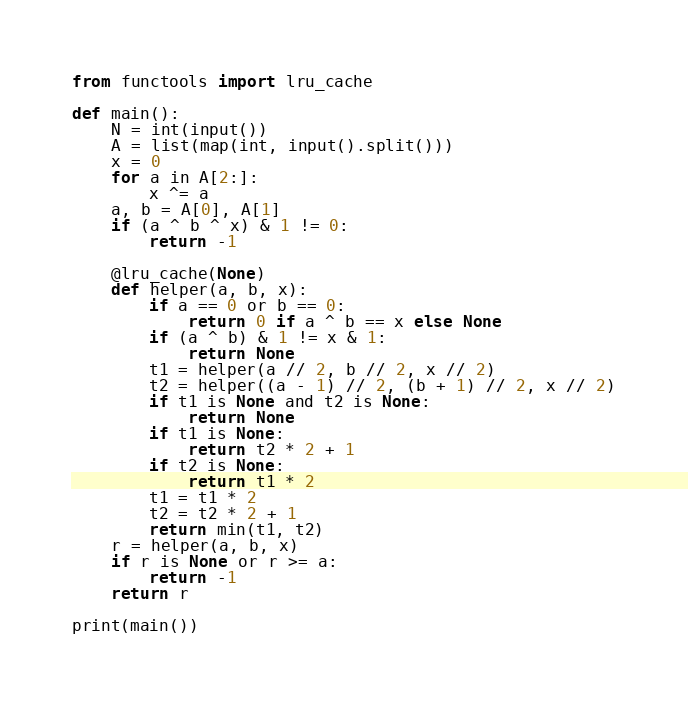Convert code to text. <code><loc_0><loc_0><loc_500><loc_500><_Python_>from functools import lru_cache

def main():
    N = int(input())
    A = list(map(int, input().split()))
    x = 0
    for a in A[2:]:
        x ^= a
    a, b = A[0], A[1]
    if (a ^ b ^ x) & 1 != 0:
        return -1

    @lru_cache(None)
    def helper(a, b, x):
        if a == 0 or b == 0:
            return 0 if a ^ b == x else None
        if (a ^ b) & 1 != x & 1:
            return None
        t1 = helper(a // 2, b // 2, x // 2)
        t2 = helper((a - 1) // 2, (b + 1) // 2, x // 2)
        if t1 is None and t2 is None:
            return None
        if t1 is None:
            return t2 * 2 + 1
        if t2 is None:
            return t1 * 2
        t1 = t1 * 2
        t2 = t2 * 2 + 1
        return min(t1, t2)
    r = helper(a, b, x)
    if r is None or r >= a:
        return -1
    return r

print(main())
</code> 